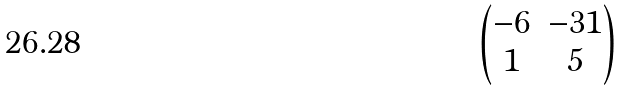Convert formula to latex. <formula><loc_0><loc_0><loc_500><loc_500>\begin{pmatrix} - 6 & - 3 1 \\ 1 & 5 \end{pmatrix}</formula> 